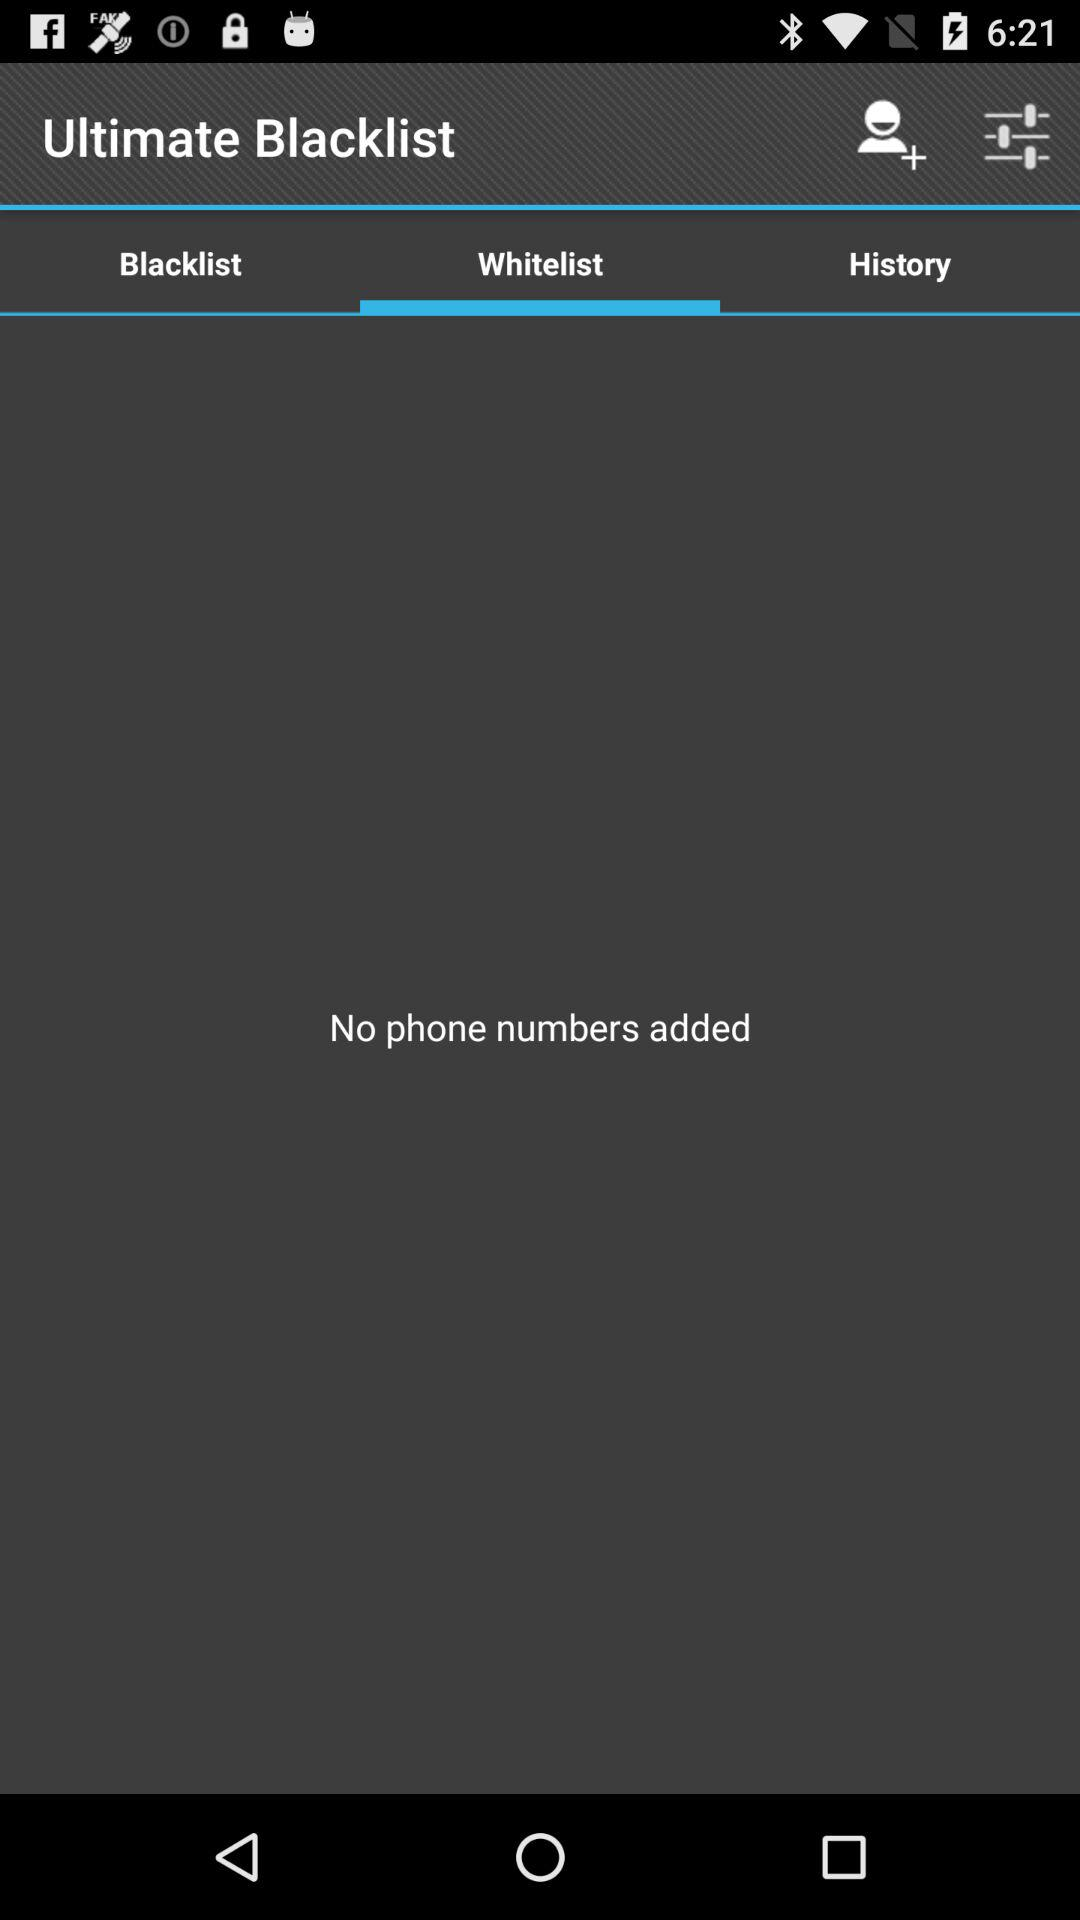Is there a phone number in the whitelist? There is no phone number in the whitelist. 